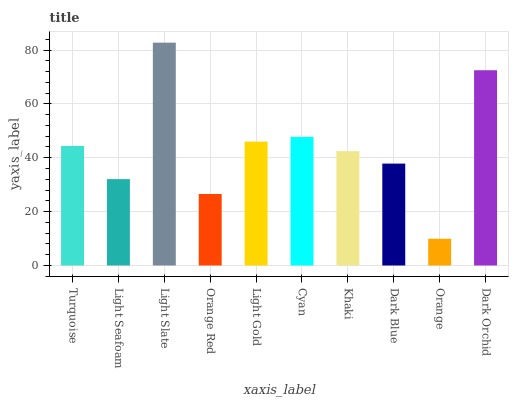Is Orange the minimum?
Answer yes or no. Yes. Is Light Slate the maximum?
Answer yes or no. Yes. Is Light Seafoam the minimum?
Answer yes or no. No. Is Light Seafoam the maximum?
Answer yes or no. No. Is Turquoise greater than Light Seafoam?
Answer yes or no. Yes. Is Light Seafoam less than Turquoise?
Answer yes or no. Yes. Is Light Seafoam greater than Turquoise?
Answer yes or no. No. Is Turquoise less than Light Seafoam?
Answer yes or no. No. Is Turquoise the high median?
Answer yes or no. Yes. Is Khaki the low median?
Answer yes or no. Yes. Is Orange the high median?
Answer yes or no. No. Is Dark Blue the low median?
Answer yes or no. No. 